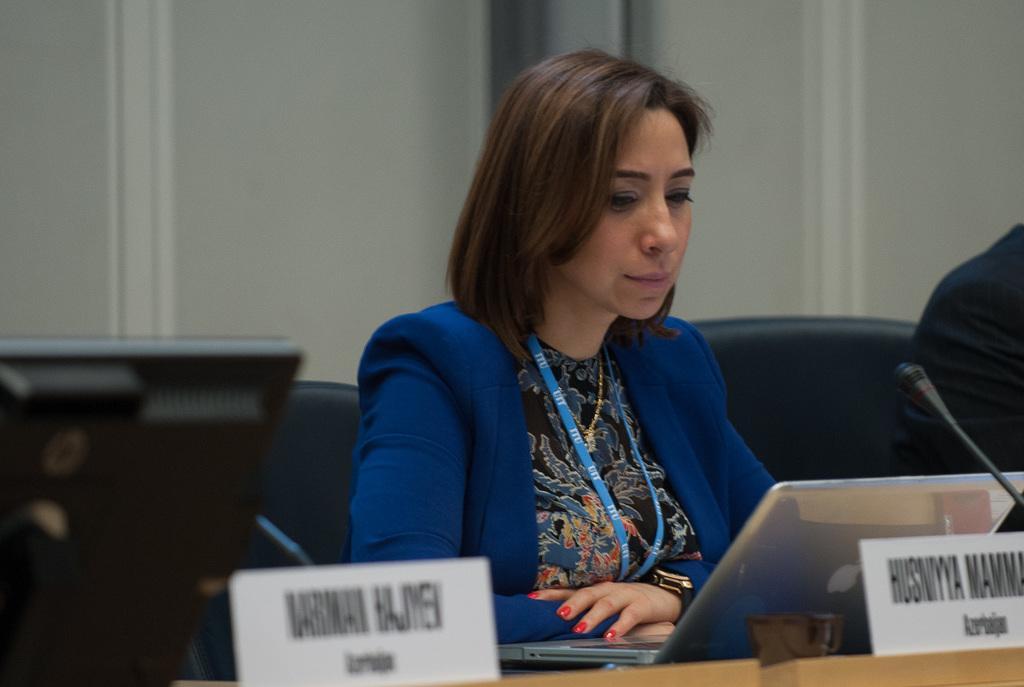Describe this image in one or two sentences. There is a woman sitting on chair, beside her we can see a person, in front of her we can see laptops, boards and microphone on the table. We can see chairs. In the background we can see wall. 